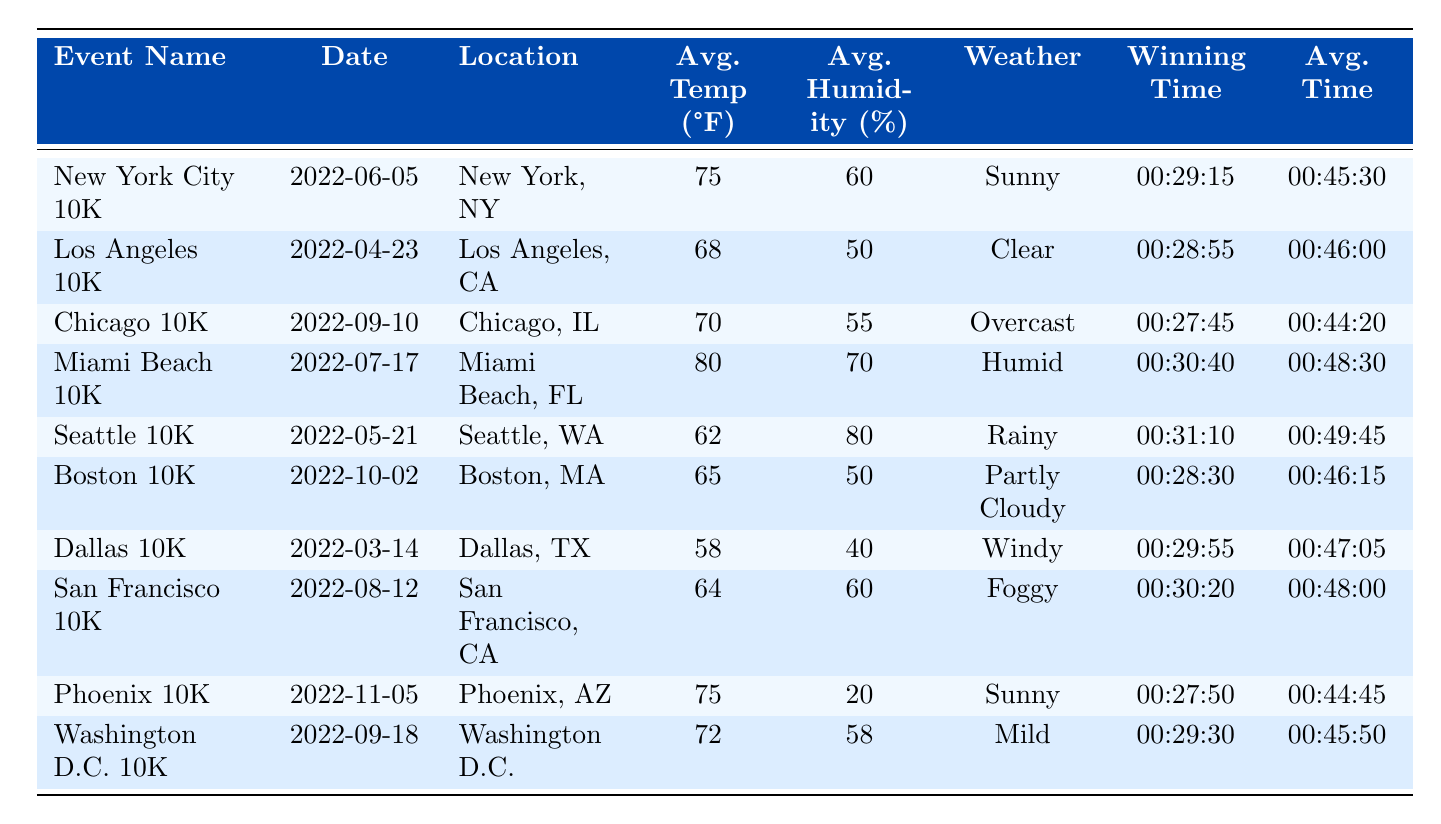What was the weather condition for the Los Angeles 10K? By referring to the table, under the "Weather" column for the "Los Angeles 10K", it shows "Clear" as the weather condition.
Answer: Clear Which event had the highest average temperature? The highest average temperature listed is 80°F for the "Miami Beach 10K".
Answer: Miami Beach 10K What is the average winning time for all events? To find the average winning time, first convert winning times to minutes: (29.25 + 28.92 + 27.75 + 30.67 + 31.17 + 28.50 + 29.92 + 30.33 + 27.83 + 29.50) = 296.33 minutes. Divide this total by the number of events (10), so 296.33 / 10 = 29.63 minutes, which is approximately 29:38 when converted back to time format.
Answer: 29:38 Was the winning time for the Chicago 10K faster than the average time for that event? The winning time for the Chicago 10K is 00:27:45, while the average time is 00:44:20. Since 27:45 is less than 44:20, we can conclude that the winning time was indeed faster.
Answer: Yes How does the average time for the Miami Beach 10K compare to the average time for the Phoenix 10K? The average time for Miami Beach 10K is 00:48:30, while for Phoenix 10K, it is 00:44:45. Since 48:30 is greater than 44:45, the average time for Miami Beach is slower than that for Phoenix.
Answer: Miami Beach is slower Which event had the fastest winning time among events with humid weather conditions? The only events categorized under humid weather conditions are the "Miami Beach 10K" with a winning time of 00:30:40. Since it's the only one listed under that condition, it is the fastest by default.
Answer: Miami Beach 10K What is the correlation between average temperature and winning time for the events? To evaluate this correlation, one must look at the average temperatures and their corresponding winning times. For example, the winning times for the highest temperatures did not consistently correspond to better times. This requires more detailed analysis to draw conclusions about correlation.
Answer: Not directly determinable Is it true that the Seattle 10K had an average humidity percentage below 70%? The average humidity for the Seattle 10K is 80%, which exceeds 70%, making the statement false.
Answer: No What was the winning time for the event held in Boston? Looking at the table, the winning time for the "Boston 10K" is listed as 00:28:30.
Answer: 00:28:30 Which location had a weather condition of "Foggy" and what was its winning time? The location with a foggy condition is "San Francisco, CA", and the winning time for the San Francisco 10K is 00:30:20.
Answer: San Francisco, CA; 00:30:20 Was any event in the table conducted in March? Yes, the "Dallas 10K" event took place on March 14, 2022.
Answer: Yes 